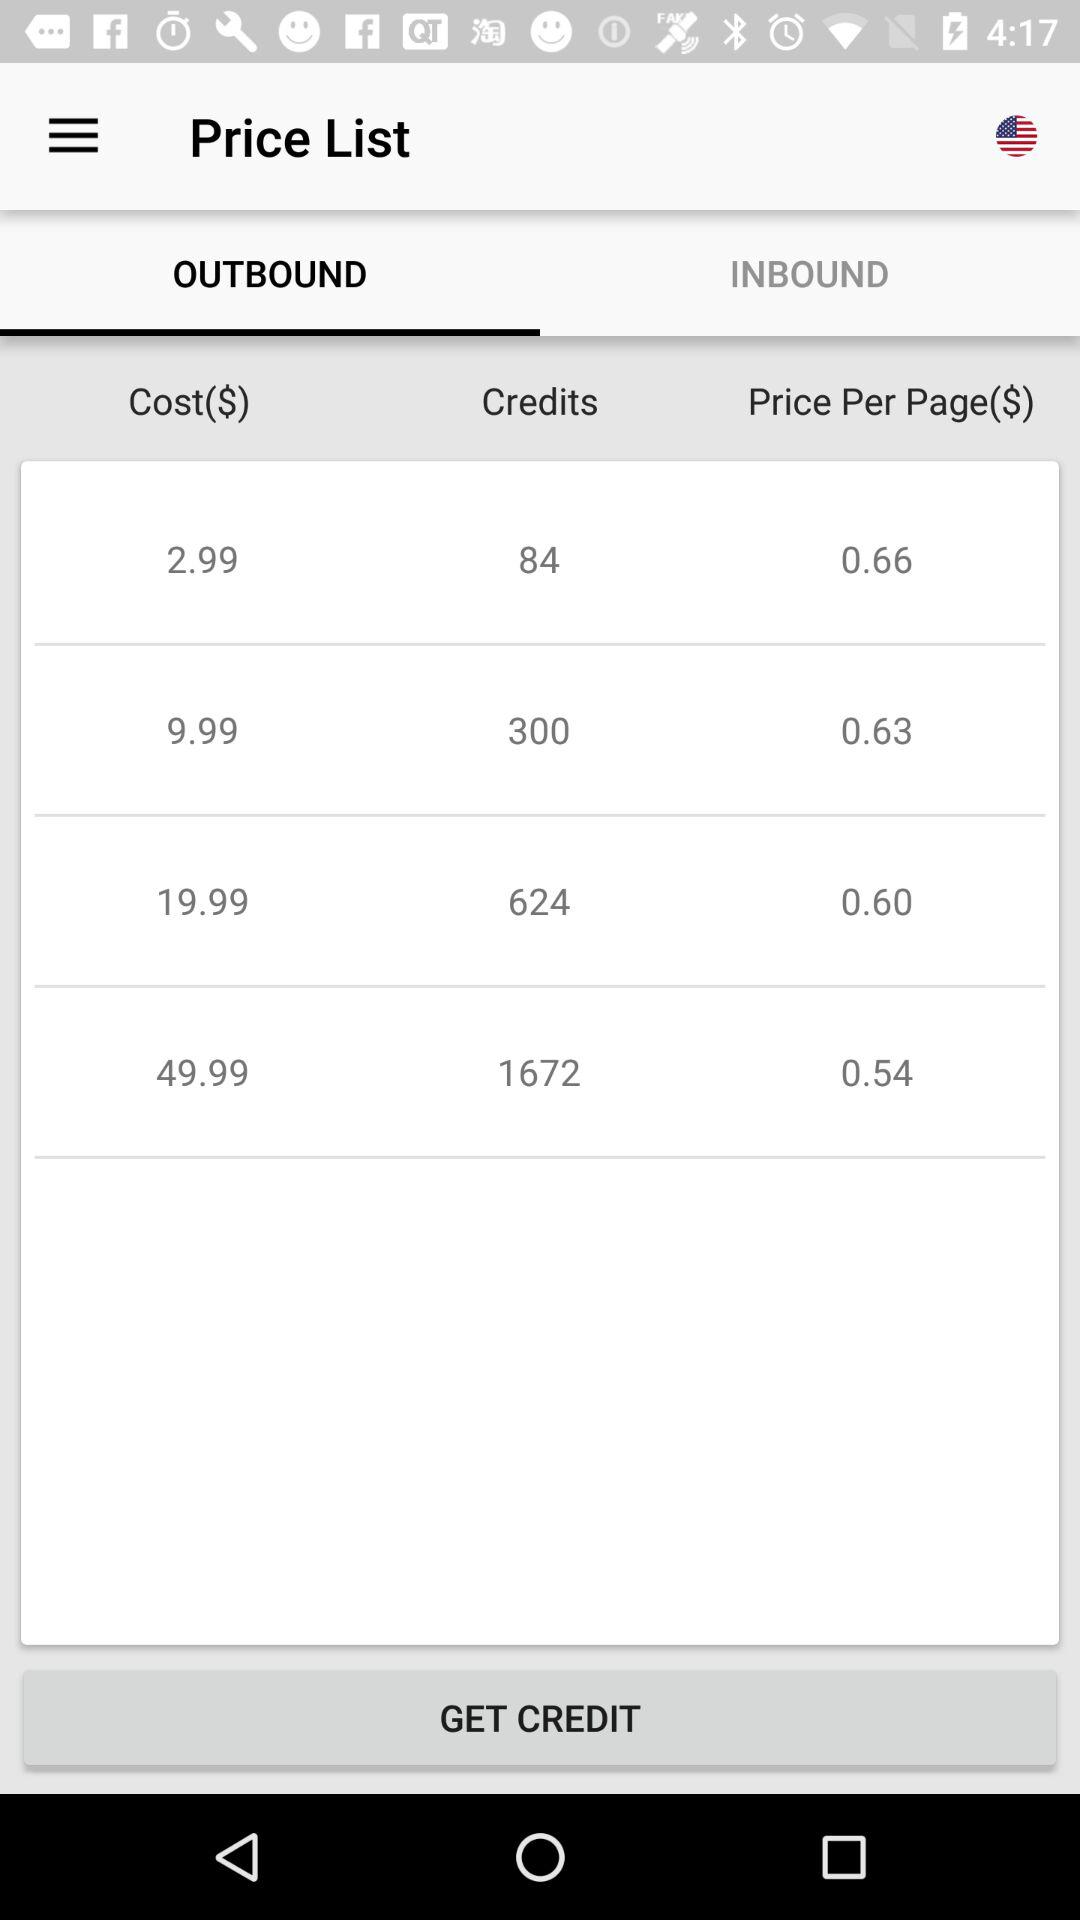What is the price of the most expensive plan?
Answer the question using a single word or phrase. 49.99 